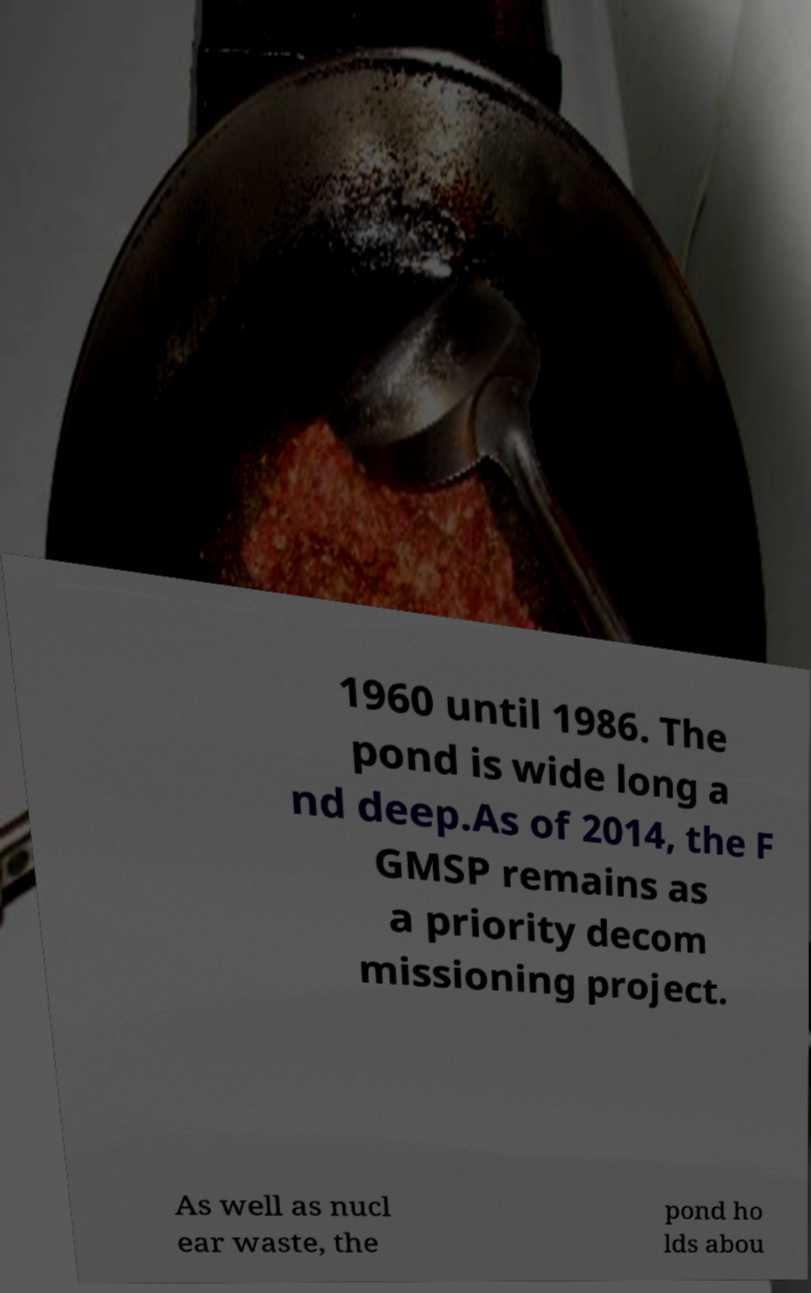Could you extract and type out the text from this image? 1960 until 1986. The pond is wide long a nd deep.As of 2014, the F GMSP remains as a priority decom missioning project. As well as nucl ear waste, the pond ho lds abou 